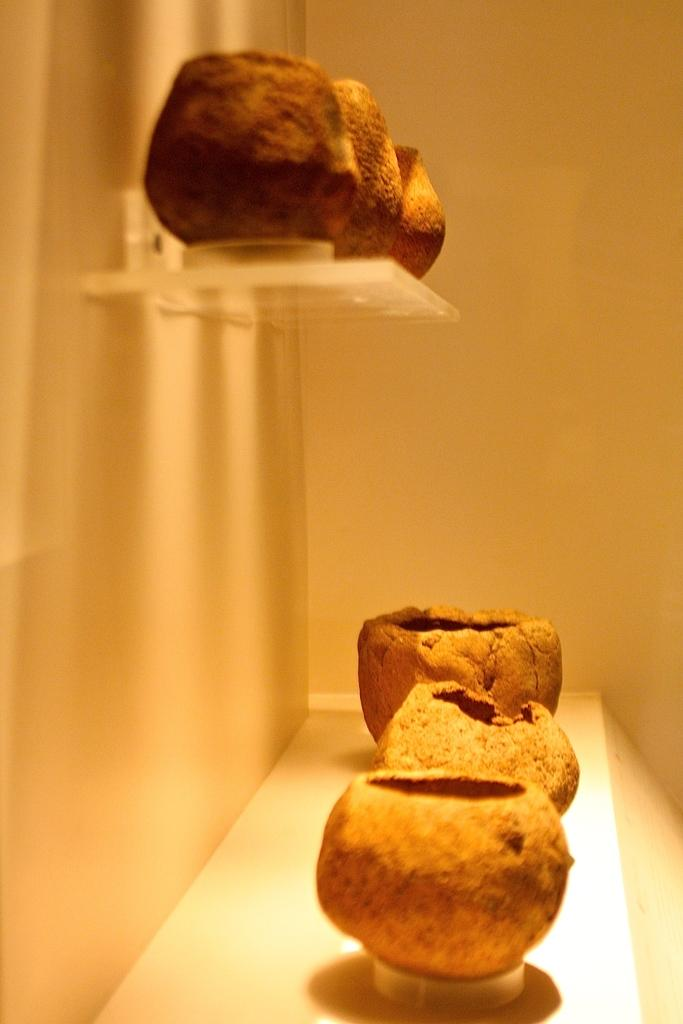What type of objects can be seen at the bottom of the image? There are mud objects on the bottom of the image. Are there any mud objects visible at the top of the image? Yes, there are mud objects on the top of the image. What can be seen in the background of the image? There is a wall in the image. What type of war is depicted in the image? There is no depiction of war in the image; it features mud objects and a wall. What kind of zephyr can be seen blowing through the image? There is no zephyr present in the image; it is a static representation of mud objects and a wall. 